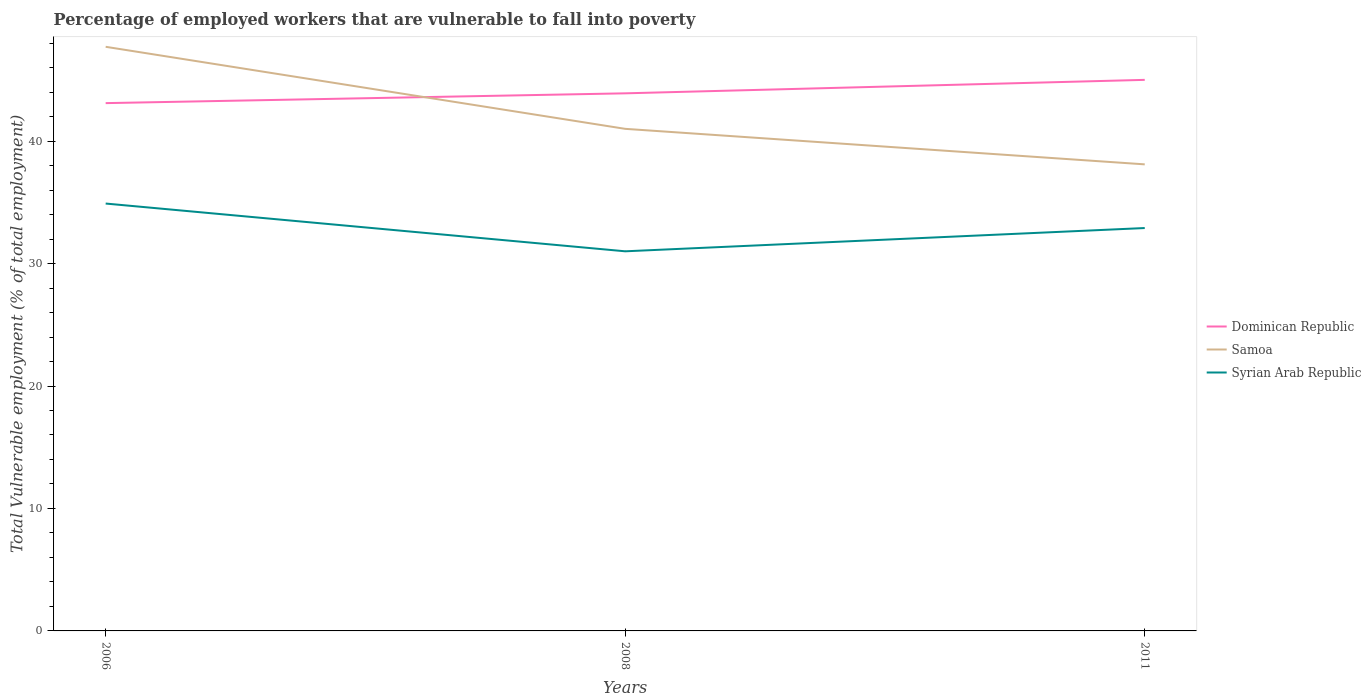How many different coloured lines are there?
Ensure brevity in your answer.  3. Does the line corresponding to Samoa intersect with the line corresponding to Dominican Republic?
Provide a short and direct response. Yes. Is the number of lines equal to the number of legend labels?
Your answer should be very brief. Yes. Across all years, what is the maximum percentage of employed workers who are vulnerable to fall into poverty in Syrian Arab Republic?
Give a very brief answer. 31. In which year was the percentage of employed workers who are vulnerable to fall into poverty in Dominican Republic maximum?
Offer a terse response. 2006. What is the total percentage of employed workers who are vulnerable to fall into poverty in Samoa in the graph?
Your answer should be compact. 9.6. What is the difference between the highest and the second highest percentage of employed workers who are vulnerable to fall into poverty in Samoa?
Give a very brief answer. 9.6. Is the percentage of employed workers who are vulnerable to fall into poverty in Syrian Arab Republic strictly greater than the percentage of employed workers who are vulnerable to fall into poverty in Samoa over the years?
Your answer should be compact. Yes. How many years are there in the graph?
Ensure brevity in your answer.  3. Are the values on the major ticks of Y-axis written in scientific E-notation?
Provide a succinct answer. No. Does the graph contain grids?
Your answer should be compact. No. Where does the legend appear in the graph?
Offer a terse response. Center right. What is the title of the graph?
Provide a succinct answer. Percentage of employed workers that are vulnerable to fall into poverty. Does "Suriname" appear as one of the legend labels in the graph?
Give a very brief answer. No. What is the label or title of the Y-axis?
Offer a very short reply. Total Vulnerable employment (% of total employment). What is the Total Vulnerable employment (% of total employment) in Dominican Republic in 2006?
Offer a terse response. 43.1. What is the Total Vulnerable employment (% of total employment) of Samoa in 2006?
Your answer should be very brief. 47.7. What is the Total Vulnerable employment (% of total employment) in Syrian Arab Republic in 2006?
Provide a short and direct response. 34.9. What is the Total Vulnerable employment (% of total employment) of Dominican Republic in 2008?
Your response must be concise. 43.9. What is the Total Vulnerable employment (% of total employment) of Samoa in 2008?
Offer a very short reply. 41. What is the Total Vulnerable employment (% of total employment) in Samoa in 2011?
Provide a succinct answer. 38.1. What is the Total Vulnerable employment (% of total employment) in Syrian Arab Republic in 2011?
Keep it short and to the point. 32.9. Across all years, what is the maximum Total Vulnerable employment (% of total employment) in Dominican Republic?
Ensure brevity in your answer.  45. Across all years, what is the maximum Total Vulnerable employment (% of total employment) in Samoa?
Provide a short and direct response. 47.7. Across all years, what is the maximum Total Vulnerable employment (% of total employment) in Syrian Arab Republic?
Your answer should be compact. 34.9. Across all years, what is the minimum Total Vulnerable employment (% of total employment) in Dominican Republic?
Provide a short and direct response. 43.1. Across all years, what is the minimum Total Vulnerable employment (% of total employment) in Samoa?
Make the answer very short. 38.1. Across all years, what is the minimum Total Vulnerable employment (% of total employment) in Syrian Arab Republic?
Make the answer very short. 31. What is the total Total Vulnerable employment (% of total employment) of Dominican Republic in the graph?
Provide a succinct answer. 132. What is the total Total Vulnerable employment (% of total employment) of Samoa in the graph?
Ensure brevity in your answer.  126.8. What is the total Total Vulnerable employment (% of total employment) of Syrian Arab Republic in the graph?
Provide a short and direct response. 98.8. What is the difference between the Total Vulnerable employment (% of total employment) of Dominican Republic in 2006 and that in 2008?
Provide a succinct answer. -0.8. What is the difference between the Total Vulnerable employment (% of total employment) of Samoa in 2006 and that in 2011?
Offer a very short reply. 9.6. What is the difference between the Total Vulnerable employment (% of total employment) of Syrian Arab Republic in 2006 and that in 2011?
Provide a short and direct response. 2. What is the difference between the Total Vulnerable employment (% of total employment) in Dominican Republic in 2006 and the Total Vulnerable employment (% of total employment) in Samoa in 2008?
Make the answer very short. 2.1. What is the difference between the Total Vulnerable employment (% of total employment) of Samoa in 2006 and the Total Vulnerable employment (% of total employment) of Syrian Arab Republic in 2008?
Provide a short and direct response. 16.7. What is the difference between the Total Vulnerable employment (% of total employment) of Dominican Republic in 2006 and the Total Vulnerable employment (% of total employment) of Samoa in 2011?
Provide a short and direct response. 5. What is the difference between the Total Vulnerable employment (% of total employment) of Dominican Republic in 2008 and the Total Vulnerable employment (% of total employment) of Samoa in 2011?
Ensure brevity in your answer.  5.8. What is the difference between the Total Vulnerable employment (% of total employment) of Dominican Republic in 2008 and the Total Vulnerable employment (% of total employment) of Syrian Arab Republic in 2011?
Keep it short and to the point. 11. What is the average Total Vulnerable employment (% of total employment) of Samoa per year?
Your answer should be compact. 42.27. What is the average Total Vulnerable employment (% of total employment) of Syrian Arab Republic per year?
Keep it short and to the point. 32.93. In the year 2006, what is the difference between the Total Vulnerable employment (% of total employment) in Dominican Republic and Total Vulnerable employment (% of total employment) in Samoa?
Offer a very short reply. -4.6. In the year 2006, what is the difference between the Total Vulnerable employment (% of total employment) in Samoa and Total Vulnerable employment (% of total employment) in Syrian Arab Republic?
Keep it short and to the point. 12.8. In the year 2008, what is the difference between the Total Vulnerable employment (% of total employment) of Dominican Republic and Total Vulnerable employment (% of total employment) of Samoa?
Provide a succinct answer. 2.9. In the year 2008, what is the difference between the Total Vulnerable employment (% of total employment) in Dominican Republic and Total Vulnerable employment (% of total employment) in Syrian Arab Republic?
Give a very brief answer. 12.9. In the year 2008, what is the difference between the Total Vulnerable employment (% of total employment) in Samoa and Total Vulnerable employment (% of total employment) in Syrian Arab Republic?
Offer a very short reply. 10. In the year 2011, what is the difference between the Total Vulnerable employment (% of total employment) of Dominican Republic and Total Vulnerable employment (% of total employment) of Samoa?
Your answer should be very brief. 6.9. In the year 2011, what is the difference between the Total Vulnerable employment (% of total employment) in Dominican Republic and Total Vulnerable employment (% of total employment) in Syrian Arab Republic?
Give a very brief answer. 12.1. What is the ratio of the Total Vulnerable employment (% of total employment) of Dominican Republic in 2006 to that in 2008?
Your answer should be very brief. 0.98. What is the ratio of the Total Vulnerable employment (% of total employment) of Samoa in 2006 to that in 2008?
Make the answer very short. 1.16. What is the ratio of the Total Vulnerable employment (% of total employment) of Syrian Arab Republic in 2006 to that in 2008?
Your response must be concise. 1.13. What is the ratio of the Total Vulnerable employment (% of total employment) of Dominican Republic in 2006 to that in 2011?
Offer a terse response. 0.96. What is the ratio of the Total Vulnerable employment (% of total employment) of Samoa in 2006 to that in 2011?
Offer a terse response. 1.25. What is the ratio of the Total Vulnerable employment (% of total employment) in Syrian Arab Republic in 2006 to that in 2011?
Keep it short and to the point. 1.06. What is the ratio of the Total Vulnerable employment (% of total employment) in Dominican Republic in 2008 to that in 2011?
Provide a short and direct response. 0.98. What is the ratio of the Total Vulnerable employment (% of total employment) of Samoa in 2008 to that in 2011?
Your response must be concise. 1.08. What is the ratio of the Total Vulnerable employment (% of total employment) in Syrian Arab Republic in 2008 to that in 2011?
Ensure brevity in your answer.  0.94. What is the difference between the highest and the second highest Total Vulnerable employment (% of total employment) in Syrian Arab Republic?
Provide a short and direct response. 2. What is the difference between the highest and the lowest Total Vulnerable employment (% of total employment) in Syrian Arab Republic?
Ensure brevity in your answer.  3.9. 